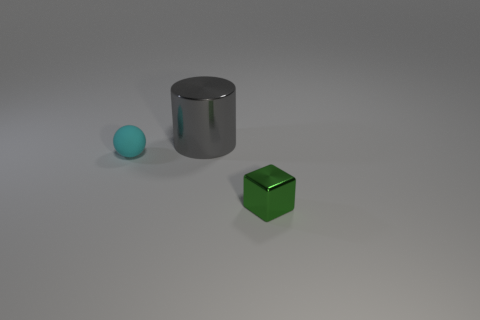What color is the metallic object behind the green thing?
Provide a succinct answer. Gray. The gray shiny thing is what shape?
Offer a very short reply. Cylinder. Is there a large gray shiny cylinder to the right of the tiny thing that is left of the small thing right of the small rubber sphere?
Provide a succinct answer. Yes. What is the color of the small object that is behind the metallic object that is in front of the tiny thing left of the metallic cube?
Make the answer very short. Cyan. There is a shiny thing that is behind the small thing that is in front of the cyan thing; what is its size?
Your answer should be compact. Large. What is the tiny object that is on the left side of the small green cube made of?
Your response must be concise. Rubber. What size is the green block that is made of the same material as the large cylinder?
Provide a succinct answer. Small. There is a large object; is it the same shape as the small object behind the small green thing?
Provide a short and direct response. No. Are there any large cubes made of the same material as the small cube?
Provide a succinct answer. No. Is there any other thing that is the same material as the cyan ball?
Keep it short and to the point. No. 